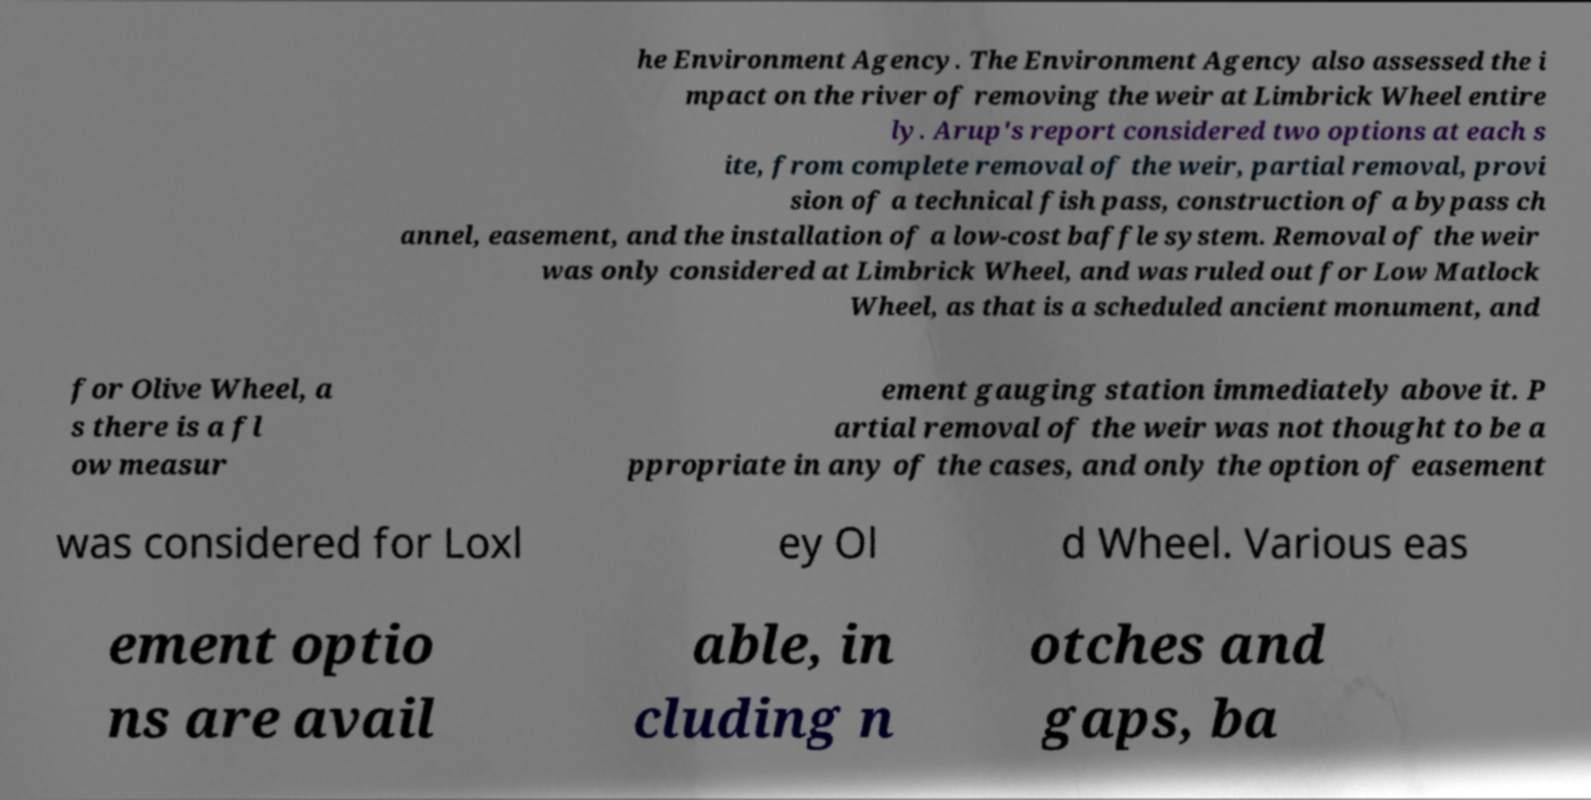Can you accurately transcribe the text from the provided image for me? he Environment Agency. The Environment Agency also assessed the i mpact on the river of removing the weir at Limbrick Wheel entire ly. Arup's report considered two options at each s ite, from complete removal of the weir, partial removal, provi sion of a technical fish pass, construction of a bypass ch annel, easement, and the installation of a low-cost baffle system. Removal of the weir was only considered at Limbrick Wheel, and was ruled out for Low Matlock Wheel, as that is a scheduled ancient monument, and for Olive Wheel, a s there is a fl ow measur ement gauging station immediately above it. P artial removal of the weir was not thought to be a ppropriate in any of the cases, and only the option of easement was considered for Loxl ey Ol d Wheel. Various eas ement optio ns are avail able, in cluding n otches and gaps, ba 